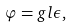Convert formula to latex. <formula><loc_0><loc_0><loc_500><loc_500>\varphi = g l \epsilon ,</formula> 